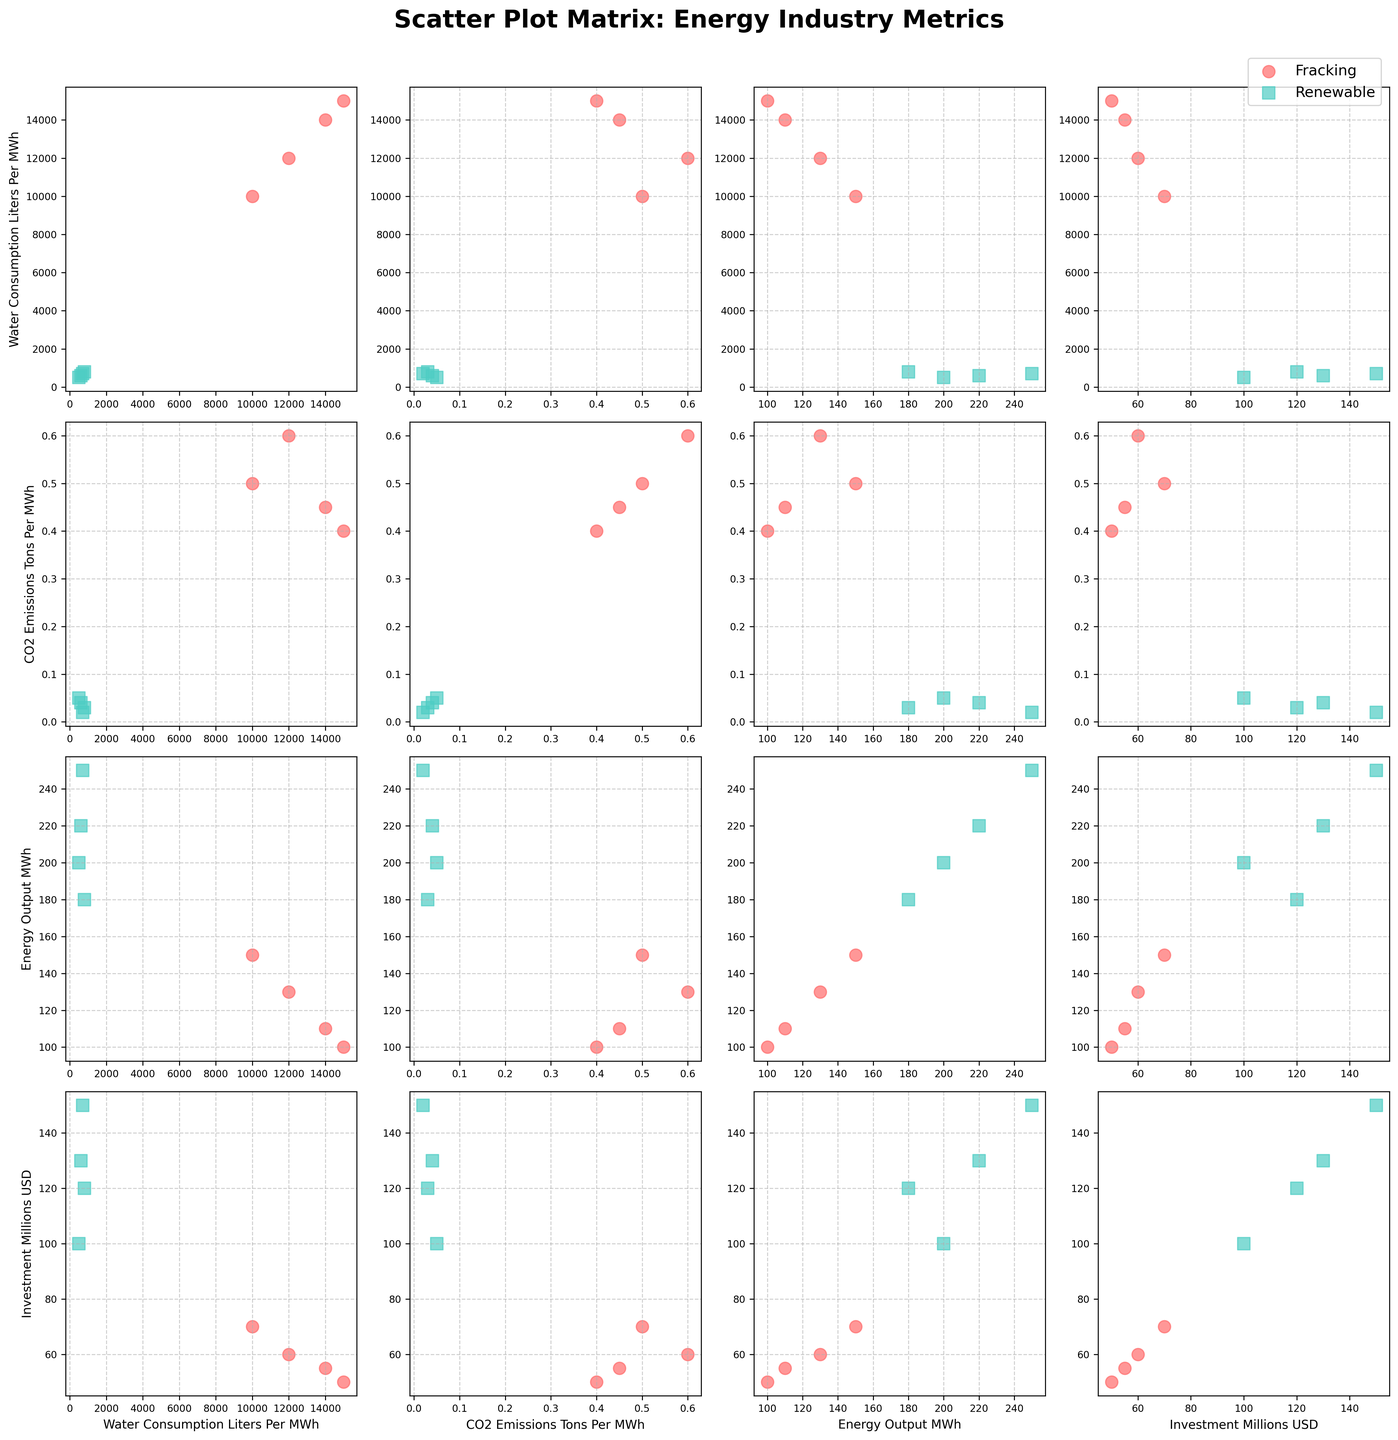What is the title of the plot? The title is displayed at the top of the figure, and it clearly mentions the subject of the plot. It reads "Scatter Plot Matrix: Energy Industry Metrics."
Answer: Scatter Plot Matrix: Energy Industry Metrics How many subplots are there in the scatter plot matrix? The figure is a 4x4 grid. This means there are 16 individual scatter plots in the matrix.
Answer: 16 What are the colors used to differentiate between Fracking and Renewable industries? The figure uses two distinct colors to differentiate the industries. Fracking is represented by a reddish color, and Renewable is represented by a greenish color.
Answer: Reddish for Fracking, Greenish for Renewable How does the water consumption for fracking compare to that of renewable energy sources? By looking at the scatter plots involving water consumption on either axis, Fracking data points are clustered at higher water consumption values (10,000 to 15,000 liters per MWh), whereas Renewable energy sources are clustered at lower values (500 to 800 liters per MWh).
Answer: Fracking has higher water consumption than Renewable energy sources Which industry has a lower CO2 emission per MWh on average? By examining the scatter plots with CO2 Emissions on one of the axes, Renewable energy points are at lower CO2 Emission values compared to Fracking.
Answer: Renewable In terms of investment, which renewable energy subcategory has the highest investment? From the scatter plots involving Investment on one axis, we see that the highest investment for Renewable is at the 150 million USD mark, which corresponds to Hydropower.
Answer: Hydropower What is the general relationship between water consumption and CO2 emissions for the Fracking industry? By focusing on the upper scatter plots where both Water Consumption and CO2 Emissions are plotted, there is a positive trend in Fracking data points suggesting that higher water consumption generally correlates with higher CO2 emissions.
Answer: Positive correlation Which industry generally achieves higher energy output per investment? By comparing scatter plots where Energy Output and Investment are involved, Renewable energy sources generally achieve higher energy output per investment than Fracking. This is observed from Renewable data points being more towards the higher energy output values relative to their investment.
Answer: Renewable Do higher levels of water consumption correlate with higher investments in Fracking? Looking at scatter plots with Water Consumption and Investment on the axes, Fracking data points cluster around higher water consumption but do not show a strong correlation with higher investment.
Answer: No strong correlation Is there any renewable energy subcategory that stands out in terms of both low CO2 emissions and high energy output? By examining scatter plots with CO2 Emissions and Energy Output, Hydropower stands out as having low CO2 emissions and high energy output compared to other renewable subcategories.
Answer: Hydropower 